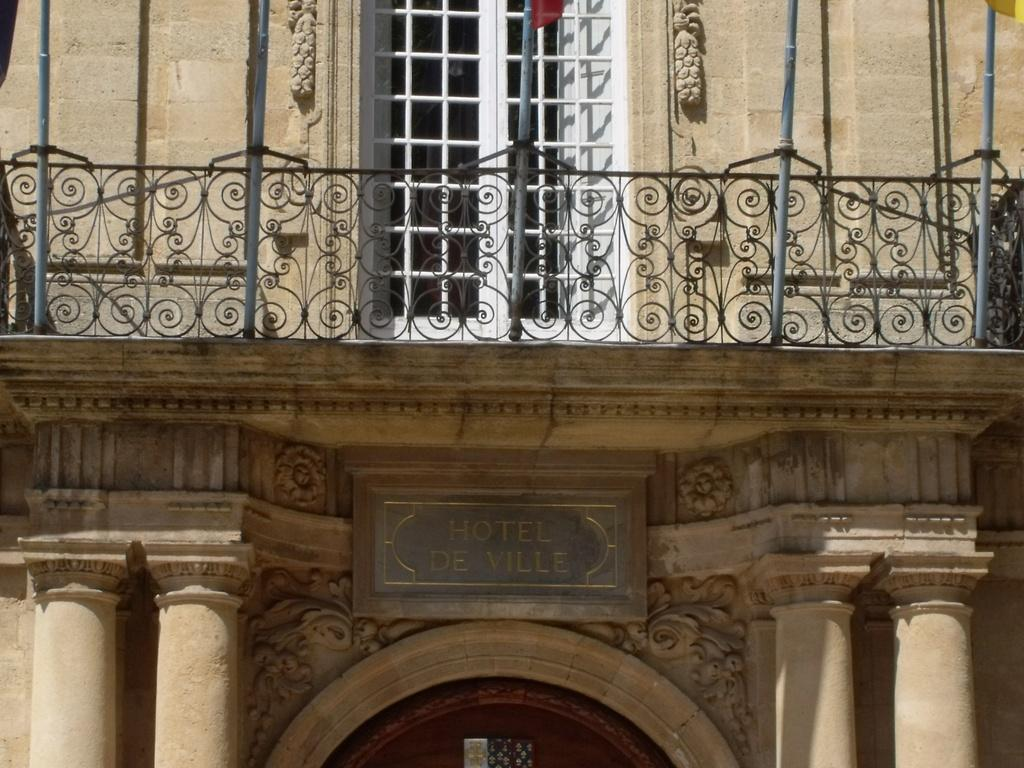What type of structure is visible in the image? There is a building in the image. What additional elements can be seen in the image? There are flags in the image. What type of camera is being used by the beginner in the image? There is no camera or beginner present in the image; it only features a building and flags. 